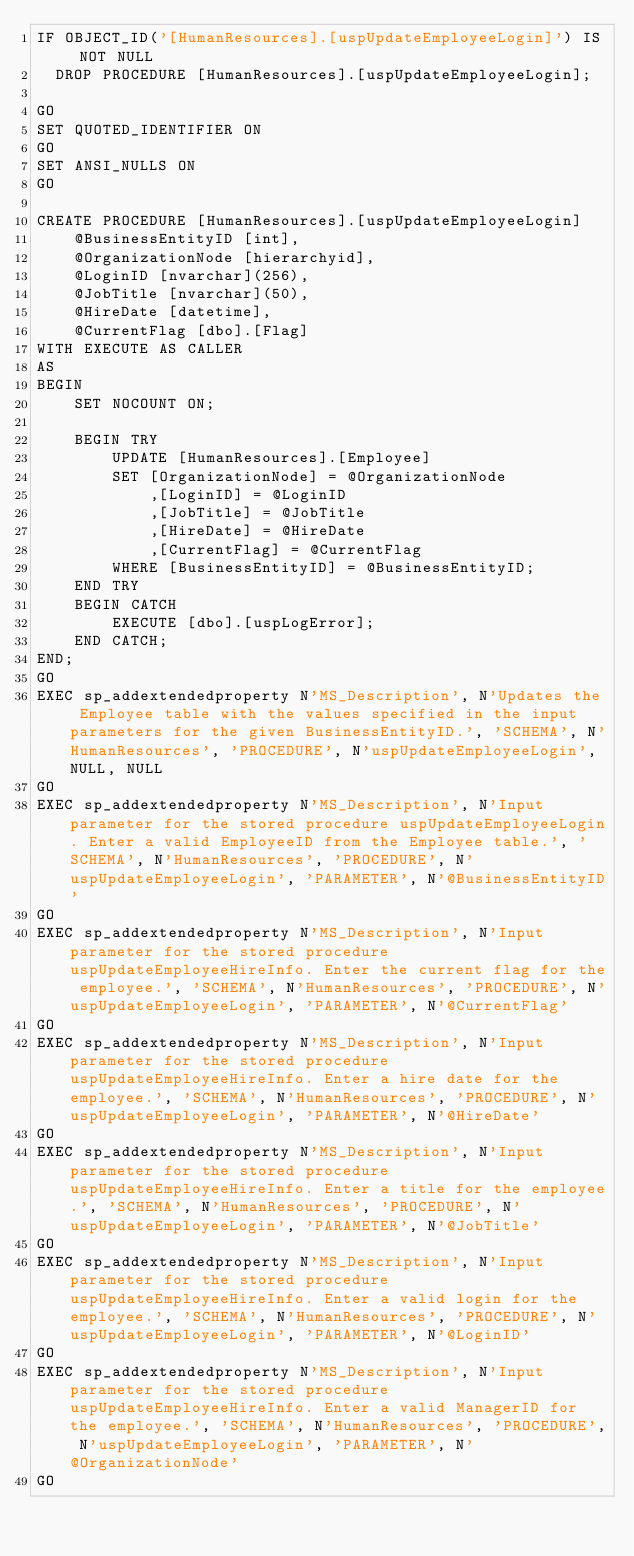<code> <loc_0><loc_0><loc_500><loc_500><_SQL_>IF OBJECT_ID('[HumanResources].[uspUpdateEmployeeLogin]') IS NOT NULL
	DROP PROCEDURE [HumanResources].[uspUpdateEmployeeLogin];

GO
SET QUOTED_IDENTIFIER ON
GO
SET ANSI_NULLS ON
GO

CREATE PROCEDURE [HumanResources].[uspUpdateEmployeeLogin]
    @BusinessEntityID [int], 
    @OrganizationNode [hierarchyid],
    @LoginID [nvarchar](256),
    @JobTitle [nvarchar](50),
    @HireDate [datetime],
    @CurrentFlag [dbo].[Flag]
WITH EXECUTE AS CALLER
AS
BEGIN
    SET NOCOUNT ON;

    BEGIN TRY
        UPDATE [HumanResources].[Employee] 
        SET [OrganizationNode] = @OrganizationNode 
            ,[LoginID] = @LoginID 
            ,[JobTitle] = @JobTitle 
            ,[HireDate] = @HireDate 
            ,[CurrentFlag] = @CurrentFlag 
        WHERE [BusinessEntityID] = @BusinessEntityID;
    END TRY
    BEGIN CATCH
        EXECUTE [dbo].[uspLogError];
    END CATCH;
END;
GO
EXEC sp_addextendedproperty N'MS_Description', N'Updates the Employee table with the values specified in the input parameters for the given BusinessEntityID.', 'SCHEMA', N'HumanResources', 'PROCEDURE', N'uspUpdateEmployeeLogin', NULL, NULL
GO
EXEC sp_addextendedproperty N'MS_Description', N'Input parameter for the stored procedure uspUpdateEmployeeLogin. Enter a valid EmployeeID from the Employee table.', 'SCHEMA', N'HumanResources', 'PROCEDURE', N'uspUpdateEmployeeLogin', 'PARAMETER', N'@BusinessEntityID'
GO
EXEC sp_addextendedproperty N'MS_Description', N'Input parameter for the stored procedure uspUpdateEmployeeHireInfo. Enter the current flag for the employee.', 'SCHEMA', N'HumanResources', 'PROCEDURE', N'uspUpdateEmployeeLogin', 'PARAMETER', N'@CurrentFlag'
GO
EXEC sp_addextendedproperty N'MS_Description', N'Input parameter for the stored procedure uspUpdateEmployeeHireInfo. Enter a hire date for the employee.', 'SCHEMA', N'HumanResources', 'PROCEDURE', N'uspUpdateEmployeeLogin', 'PARAMETER', N'@HireDate'
GO
EXEC sp_addextendedproperty N'MS_Description', N'Input parameter for the stored procedure uspUpdateEmployeeHireInfo. Enter a title for the employee.', 'SCHEMA', N'HumanResources', 'PROCEDURE', N'uspUpdateEmployeeLogin', 'PARAMETER', N'@JobTitle'
GO
EXEC sp_addextendedproperty N'MS_Description', N'Input parameter for the stored procedure uspUpdateEmployeeHireInfo. Enter a valid login for the employee.', 'SCHEMA', N'HumanResources', 'PROCEDURE', N'uspUpdateEmployeeLogin', 'PARAMETER', N'@LoginID'
GO
EXEC sp_addextendedproperty N'MS_Description', N'Input parameter for the stored procedure uspUpdateEmployeeHireInfo. Enter a valid ManagerID for the employee.', 'SCHEMA', N'HumanResources', 'PROCEDURE', N'uspUpdateEmployeeLogin', 'PARAMETER', N'@OrganizationNode'
GO
</code> 